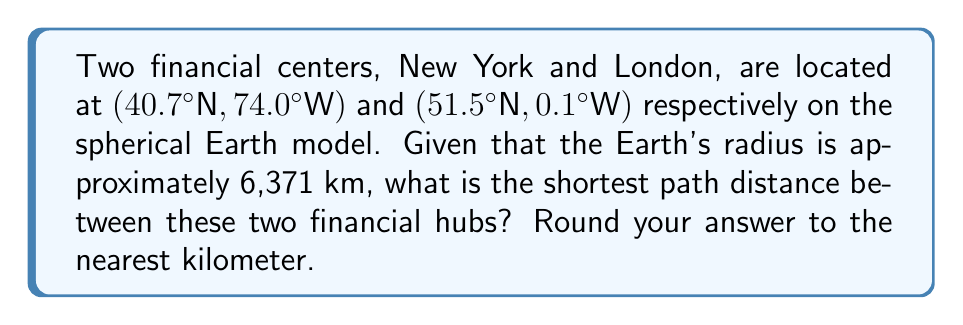Provide a solution to this math problem. To solve this problem, we'll use the great circle distance formula, which gives the shortest path between two points on a sphere. The steps are as follows:

1) First, we need to convert the latitudes and longitudes from degrees to radians:

   New York: $\phi_1 = 40.7° \times \frac{\pi}{180} = 0.7101$ rad
             $\lambda_1 = -74.0° \times \frac{\pi}{180} = -1.2915$ rad
   
   London:   $\phi_2 = 51.5° \times \frac{\pi}{180} = 0.8987$ rad
             $\lambda_2 = -0.1° \times \frac{\pi}{180} = -0.0017$ rad

2) Next, we'll use the haversine formula to calculate the central angle $\Delta\sigma$ between the two points:

   $$\Delta\sigma = 2 \arcsin\left(\sqrt{\sin^2\left(\frac{\phi_2-\phi_1}{2}\right) + \cos\phi_1 \cos\phi_2 \sin^2\left(\frac{\lambda_2-\lambda_1}{2}\right)}\right)$$

3) Plugging in our values:

   $$\Delta\sigma = 2 \arcsin\left(\sqrt{\sin^2\left(\frac{0.8987-0.7101}{2}\right) + \cos(0.7101) \cos(0.8987) \sin^2\left(\frac{-0.0017-(-1.2915)}{2}\right)}\right)$$

4) Calculating this gives us:
   
   $\Delta\sigma \approx 0.9820$ radians

5) The distance $d$ is then calculated by multiplying this angle by the Earth's radius $R$:

   $d = R \times \Delta\sigma = 6371 \times 0.9820 \approx 6255.7$ km

6) Rounding to the nearest kilometer:

   $d \approx 6256$ km

This represents the most cost-effective route for data transmission or travel between these two financial centers.
Answer: 6256 km 